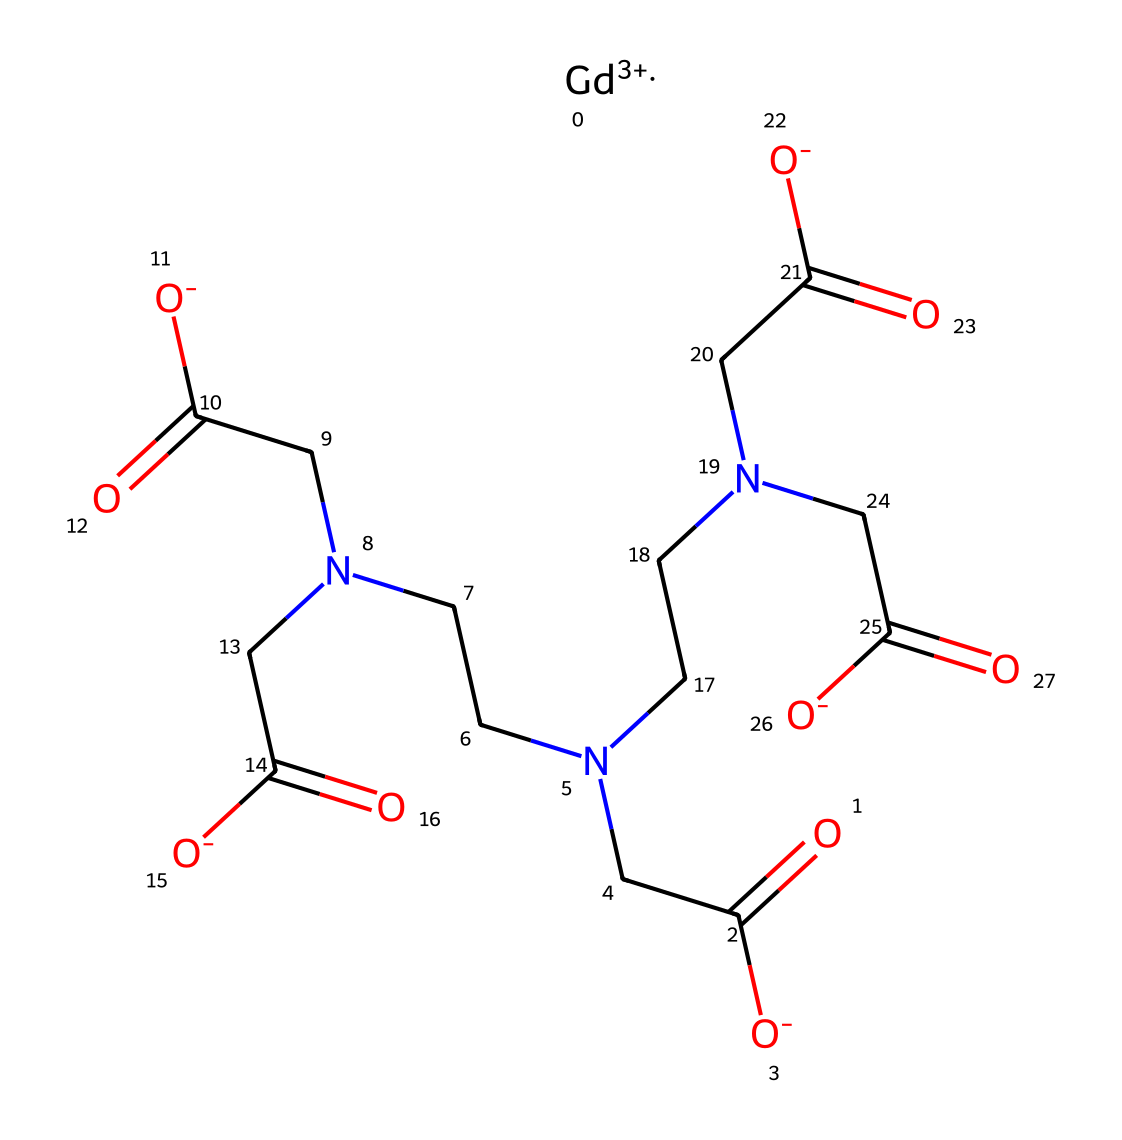how many carbon atoms are present in the structure? By examining the SMILES representation, I can count the carbon atoms (C) present. There are several instances of "CC" and "(C" indicating at least 10 carbon atoms in total.
Answer: 10 what is the central metal ion in this chemical? In the SMILES notation, "[Gd+3]" indicates the presence of gadolinium as the central metal ion.
Answer: gadolinium how many nitrogen atoms are in the structure? The SMILES representation includes several "N" symbols. Counting these, there are four nitrogen atoms located within the various parts of the structure.
Answer: 4 is this structure a ligand or a complex? The presence of a central metal ion (gadolinium) surrounded by ligands (the organic parts), implies that this compound is a complex.
Answer: complex which functional groups are present in the chemical? Analyzing the structure, I see functional groups like carboxylate (–COO−) indicated by "O=C([O-])" and amine groups (–NH) shown by "CN". These represent both carboxylic acid derivatives and amines.
Answer: carboxylate and amine what type of organometallic compound is this? Given that it includes a metal center (gadolinium) and is used in medical imaging, this is classified as a gadolinium-based MRI contrast agent.
Answer: gadolinium-based contrast agent how many total oxygen atoms can be found in the structure? By inspecting the SMILES representation, I identify several instances of "O" in conjunction with the carboxylate groups, leading to a total of six oxygen atoms present in the structure.
Answer: 6 